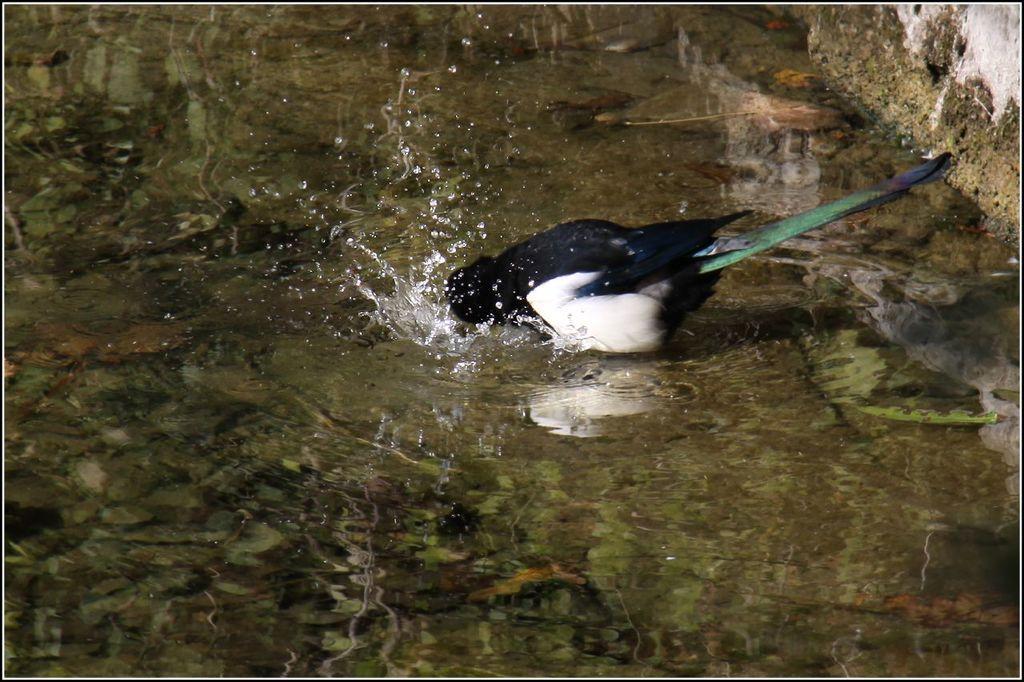Could you give a brief overview of what you see in this image? In the middle of this image there is a bird in the water. In the top right-hand corner there is a wall. 